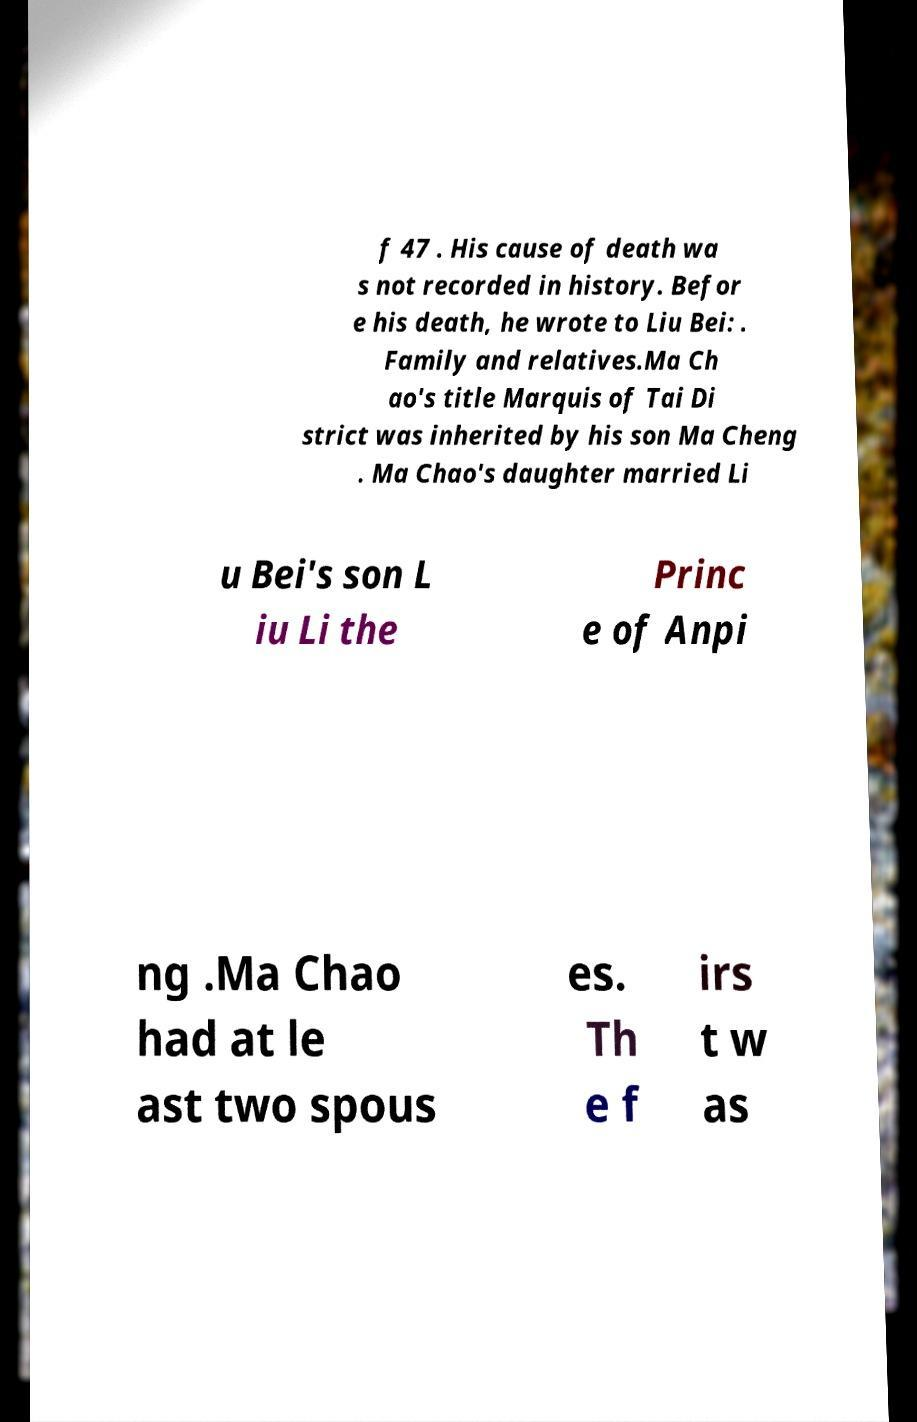Please identify and transcribe the text found in this image. f 47 . His cause of death wa s not recorded in history. Befor e his death, he wrote to Liu Bei: . Family and relatives.Ma Ch ao's title Marquis of Tai Di strict was inherited by his son Ma Cheng . Ma Chao's daughter married Li u Bei's son L iu Li the Princ e of Anpi ng .Ma Chao had at le ast two spous es. Th e f irs t w as 